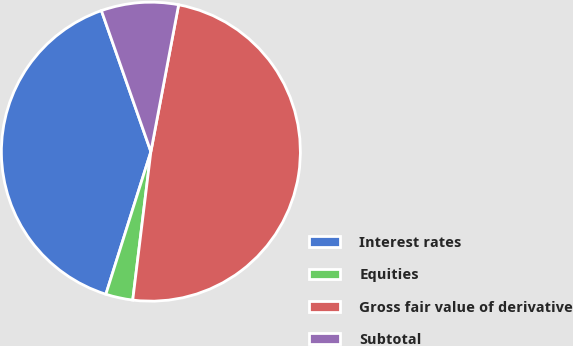Convert chart to OTSL. <chart><loc_0><loc_0><loc_500><loc_500><pie_chart><fcel>Interest rates<fcel>Equities<fcel>Gross fair value of derivative<fcel>Subtotal<nl><fcel>39.77%<fcel>2.93%<fcel>48.97%<fcel>8.34%<nl></chart> 